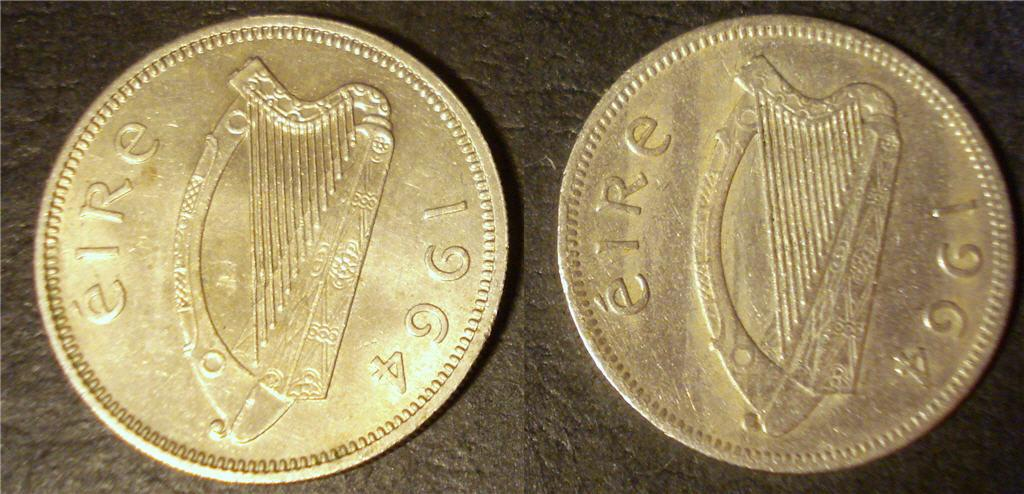<image>
Offer a succinct explanation of the picture presented. Two coins next to one another and both from the year 1964. 